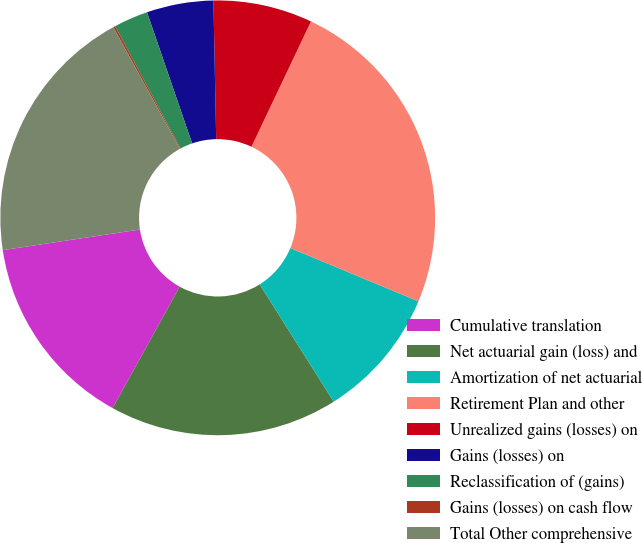Convert chart. <chart><loc_0><loc_0><loc_500><loc_500><pie_chart><fcel>Cumulative translation<fcel>Net actuarial gain (loss) and<fcel>Amortization of net actuarial<fcel>Retirement Plan and other<fcel>Unrealized gains (losses) on<fcel>Gains (losses) on<fcel>Reclassification of (gains)<fcel>Gains (losses) on cash flow<fcel>Total Other comprehensive<nl><fcel>14.59%<fcel>16.99%<fcel>9.77%<fcel>24.22%<fcel>7.37%<fcel>4.96%<fcel>2.55%<fcel>0.15%<fcel>19.4%<nl></chart> 